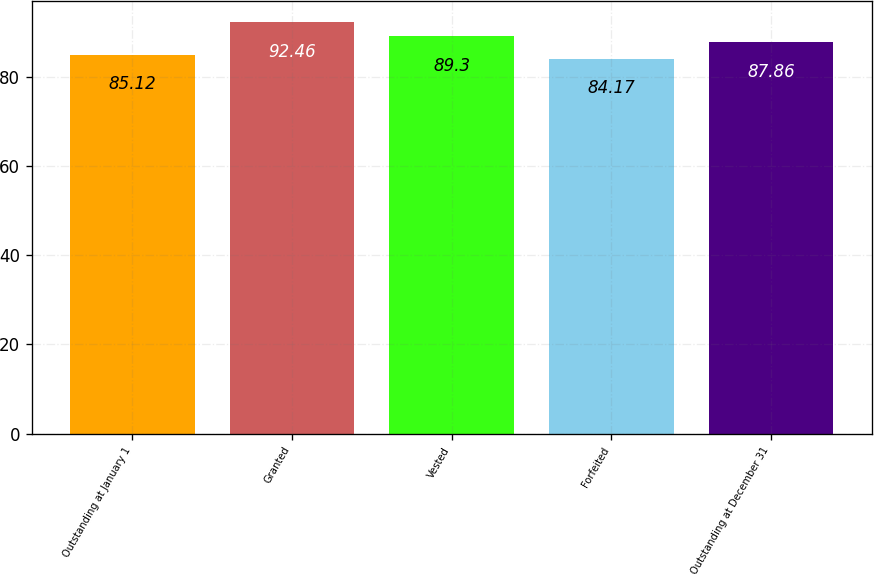Convert chart. <chart><loc_0><loc_0><loc_500><loc_500><bar_chart><fcel>Outstanding at January 1<fcel>Granted<fcel>Vested<fcel>Forfeited<fcel>Outstanding at December 31<nl><fcel>85.12<fcel>92.46<fcel>89.3<fcel>84.17<fcel>87.86<nl></chart> 